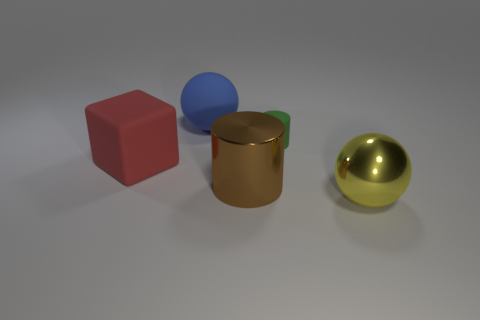Do the shiny object to the right of the brown metal object and the green cylinder have the same size? The golden sphere to the right of the bronze cylinder appears to be slightly larger when compared to the green cylinder’s cap. While the difference in size might not be very significant, upon closer inspection, the sphere’s diameter exceeds that of the green cylinder’s cap. 